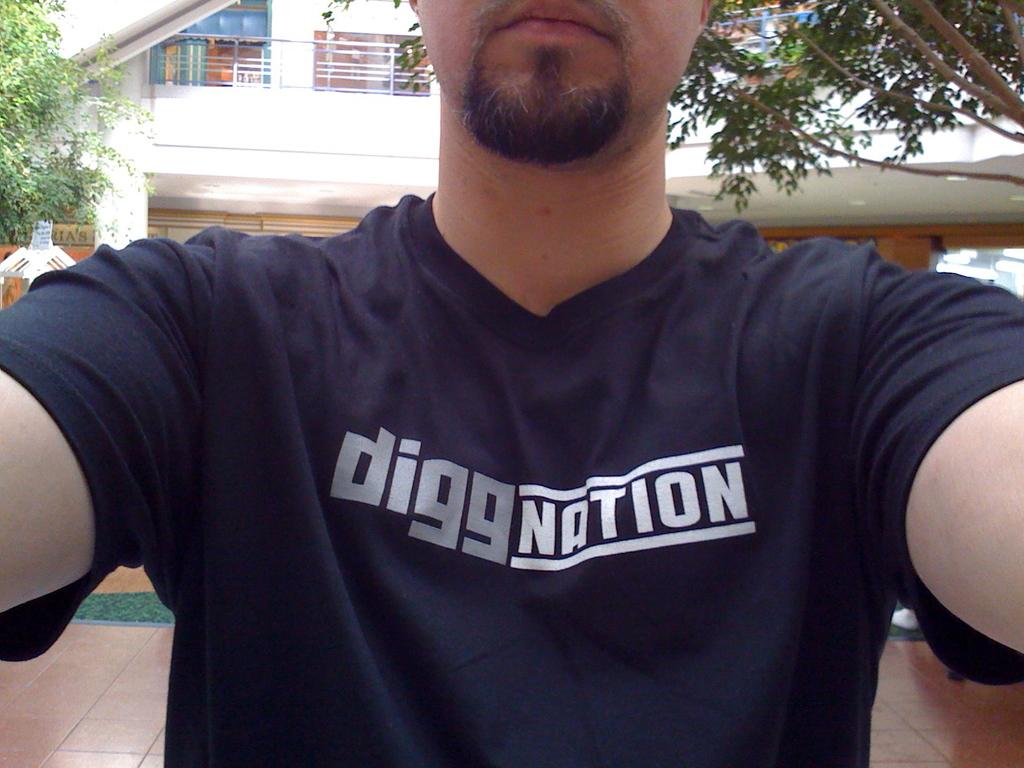What does the shirt say?
Your answer should be very brief. Diggnation. 